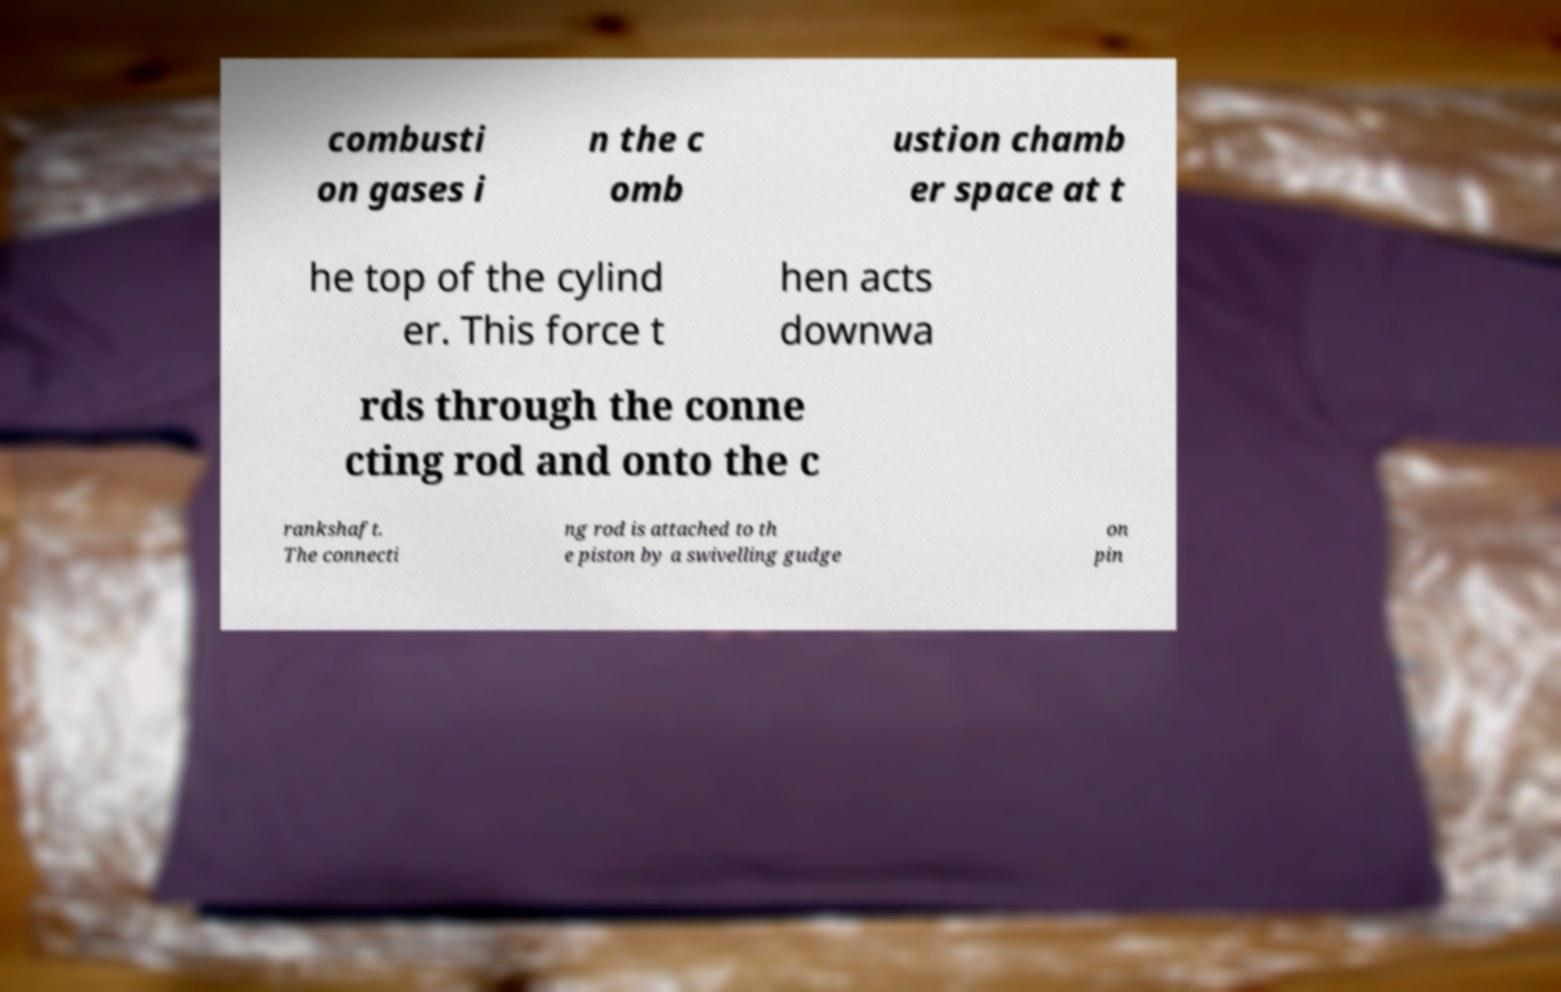Please identify and transcribe the text found in this image. combusti on gases i n the c omb ustion chamb er space at t he top of the cylind er. This force t hen acts downwa rds through the conne cting rod and onto the c rankshaft. The connecti ng rod is attached to th e piston by a swivelling gudge on pin 